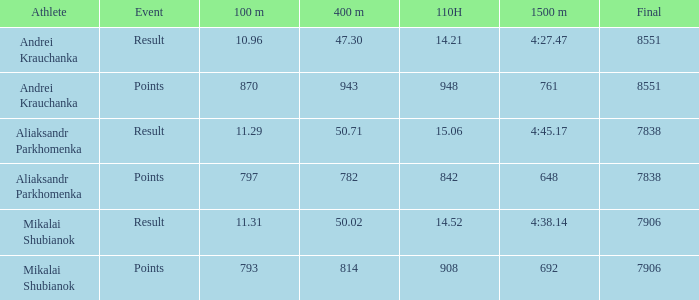When the 110h had a time less than 14.52 and the 400m had a time greater than 47.3, what was the time for the 100m race? None. 